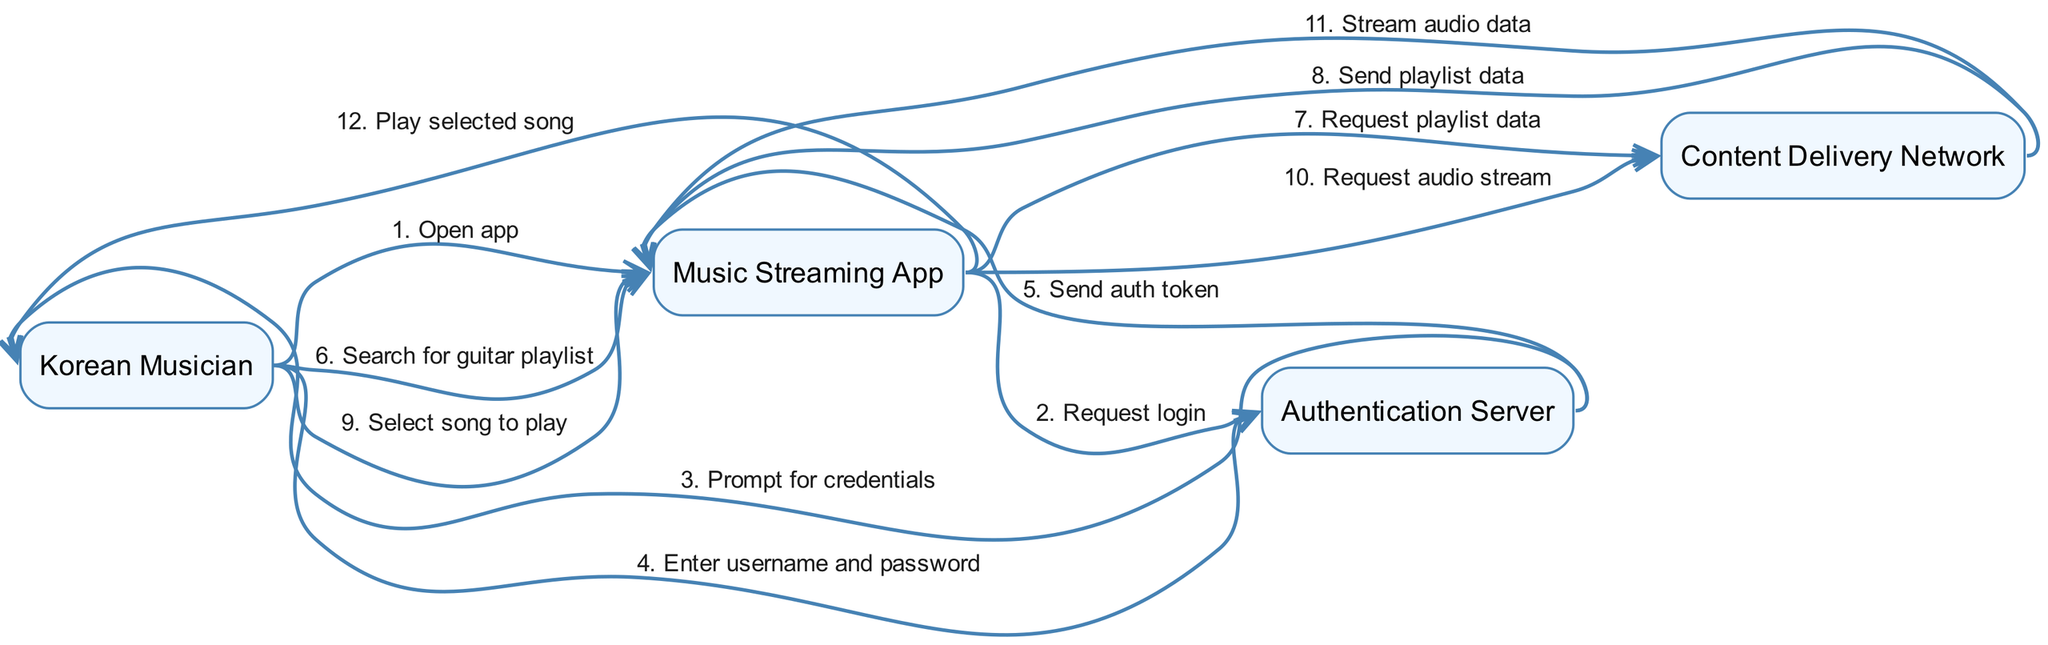What is the first action performed by the Korean Musician? The first action in the sequence is "Open app," which is directly initiated by the Korean Musician before any other interactions occur.
Answer: Open app How many actors are present in the diagram? The diagram includes four distinct actors: Korean Musician, Music Streaming App, Authentication Server, and Content Delivery Network, thus totaling four actors.
Answer: 4 What does the Authentication Server prompt the Korean Musician for? The Authentication Server prompts the Korean Musician for "credentials," indicating that the musician needs to provide login information to proceed.
Answer: credentials What action does the Music Streaming App take after receiving the authentication token? After receiving the authentication token, the Music Streaming App allows the Korean Musician to "Search for guitar playlist," indicating that authentication was successful and the app is now functional for search.
Answer: Search for guitar playlist Which component sends the audio stream to the Music Streaming App? The Content Delivery Network is responsible for sending the "Stream audio data" to the Music Streaming App upon request, which enables playback of the selected song.
Answer: Stream audio data What is the total number of messages exchanged between the Korean Musician and the Authentication Server? There are three messages exchanged: "Prompt for credentials," "Enter username and password," and "Send auth token." This totals to three messages regarding authentication.
Answer: 3 What is the last action performed in the sequence? The last action in the sequence is "Play selected song," which indicates that the process of playing has been initiated after the musician selects a song successfully.
Answer: Play selected song What action follows the request for audio stream? After the request for audio stream, the next action is "Stream audio data," which happens as a response from the Content Delivery Network to fulfill the audio streaming request.
Answer: Stream audio data How does the Korean Musician interact with the Music Streaming App after logging in? Once logged in, the Korean Musician interacts with the Music Streaming App by searching for a "guitar playlist," demonstrating engagement with the app's features next.
Answer: Search for guitar playlist 